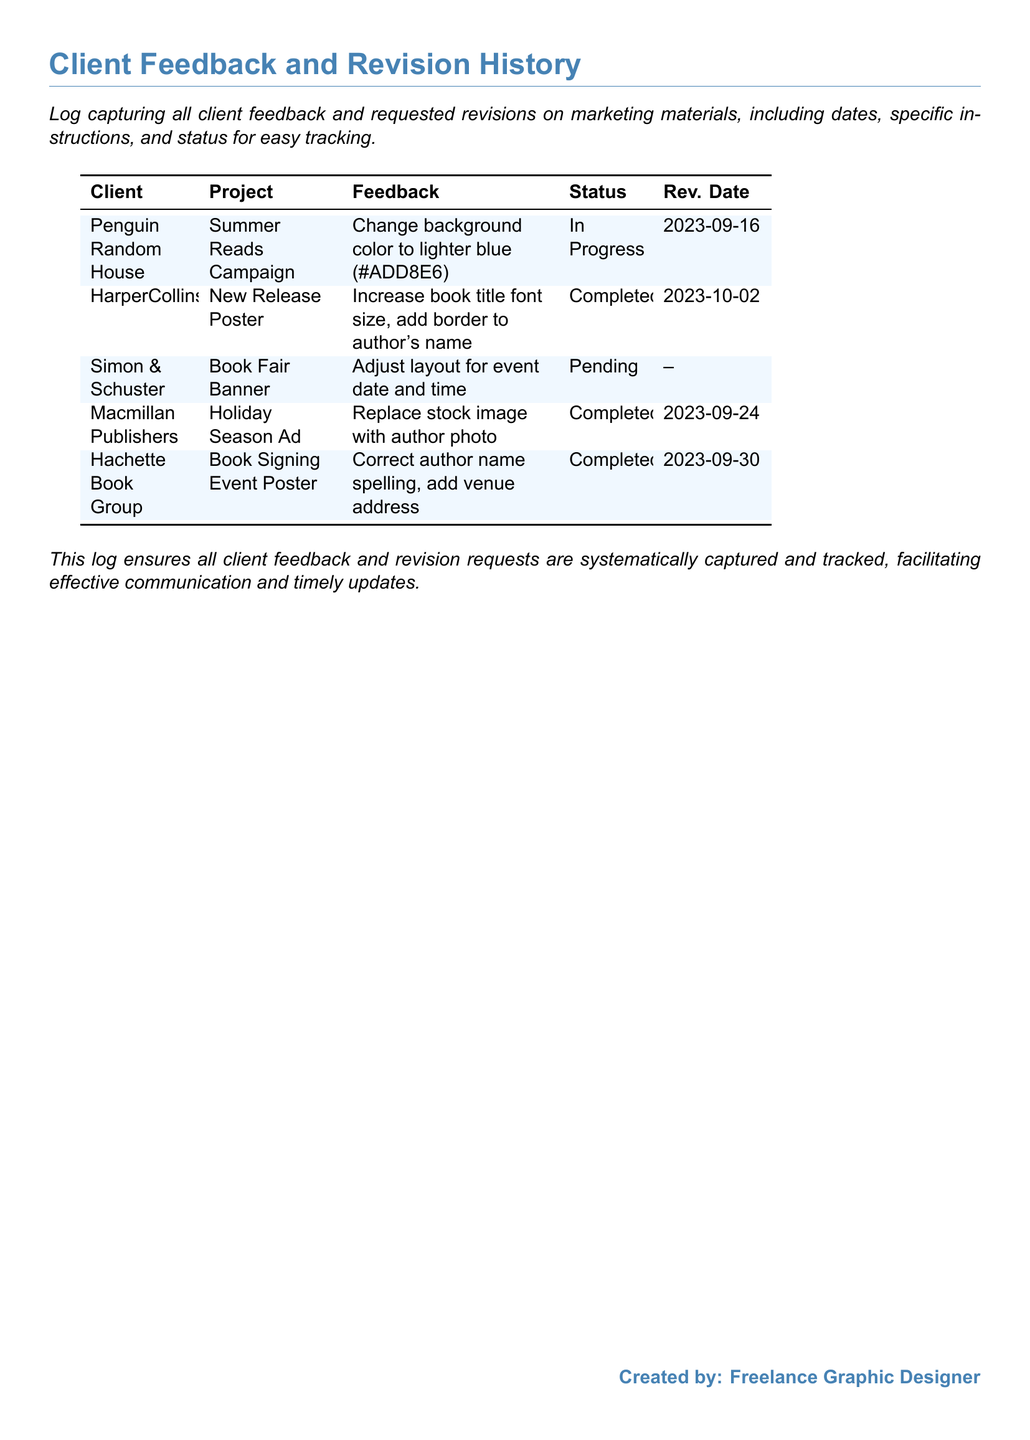What is the first client's name? The first client listed in the log is Penguin Random House.
Answer: Penguin Random House What is the status of the Summer Reads Campaign revision? The status for the Summer Reads Campaign is indicated as In Progress.
Answer: In Progress Which project had its revision completed on September 30, 2023? The project with revision completed on that date is the Book Signing Event Poster.
Answer: Book Signing Event Poster How many projects are currently pending revisions? There is one project that is currently marked as Pending.
Answer: One What specific change was requested by HarperCollins? HarperCollins requested an increase in font size for the book title and added a border to the author's name.
Answer: Increase book title font size, add border to author's name Which project is associated with Macmillan Publishers? The project associated with Macmillan Publishers is the Holiday Season Ad.
Answer: Holiday Season Ad Was the author's name spelling correction completed? Yes, the author's name spelling correction for the Book Signing Event Poster was marked as Completed.
Answer: Yes What color was requested to change in the Summer Reads Campaign? The requested change for the background color was to a lighter blue (#ADD8E6).
Answer: Lighter blue (#ADD8E6) 